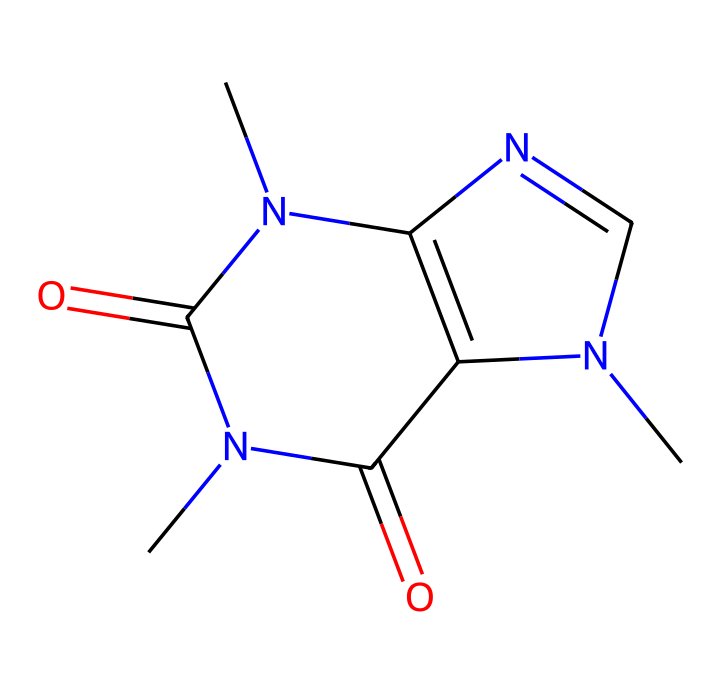What is the molecular formula of caffeine? To determine the molecular formula, we analyze the SMILES representation, counting each type of atom present: there are 8 carbons (C), 10 hydrogens (H), 4 nitrogens (N), and 2 oxygens (O), leading to the molecular formula C8H10N4O2.
Answer: C8H10N4O2 How many nitrogen atoms are there in caffeine? By examining the SMILES representation, we identify 4 'N' symbols, indicating the number of nitrogen atoms present in the molecule.
Answer: 4 Is caffeine an aromatic compound? The structure of caffeine includes nitrogen atoms in a ring, but lacks a complete conjugated pi system typical of aromatic compounds (like benzene); thus, it is categorized as a methylated xanthine rather than aromatic.
Answer: No Does caffeine contain any double bonds? The structure shows '=' signs, indicating double bonds between certain atoms in the molecule; specifically, there are two C=O double bonds and one C=N double bond.
Answer: Yes What kind of compound is caffeine based on its structure? Analyzing the SMILES representation reveals that caffeine is a nitrogen-containing base with a fused ring structure that classifies it as an alkaloid, known for pharmacological effects.
Answer: Alkaloid How many rings are present in the caffeine structure? By examining the SMILES, we recognize the two interconnected rings present in the caffeine molecule. This is characterized by the cyclic structures indicated by 'C' connected to 'N' atoms.
Answer: 2 What type of functional groups are present in caffeine? In the SMILES representation, we can observe carbonyl groups (C=O) and amine groups (N), which are functional groups fundamental to caffeine's reactivity and properties.
Answer: Carbonyl and amine 